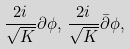<formula> <loc_0><loc_0><loc_500><loc_500>\frac { 2 i } { \sqrt { K } } \partial \phi , \, \frac { 2 i } { \sqrt { K } } \bar { \partial } \phi ,</formula> 